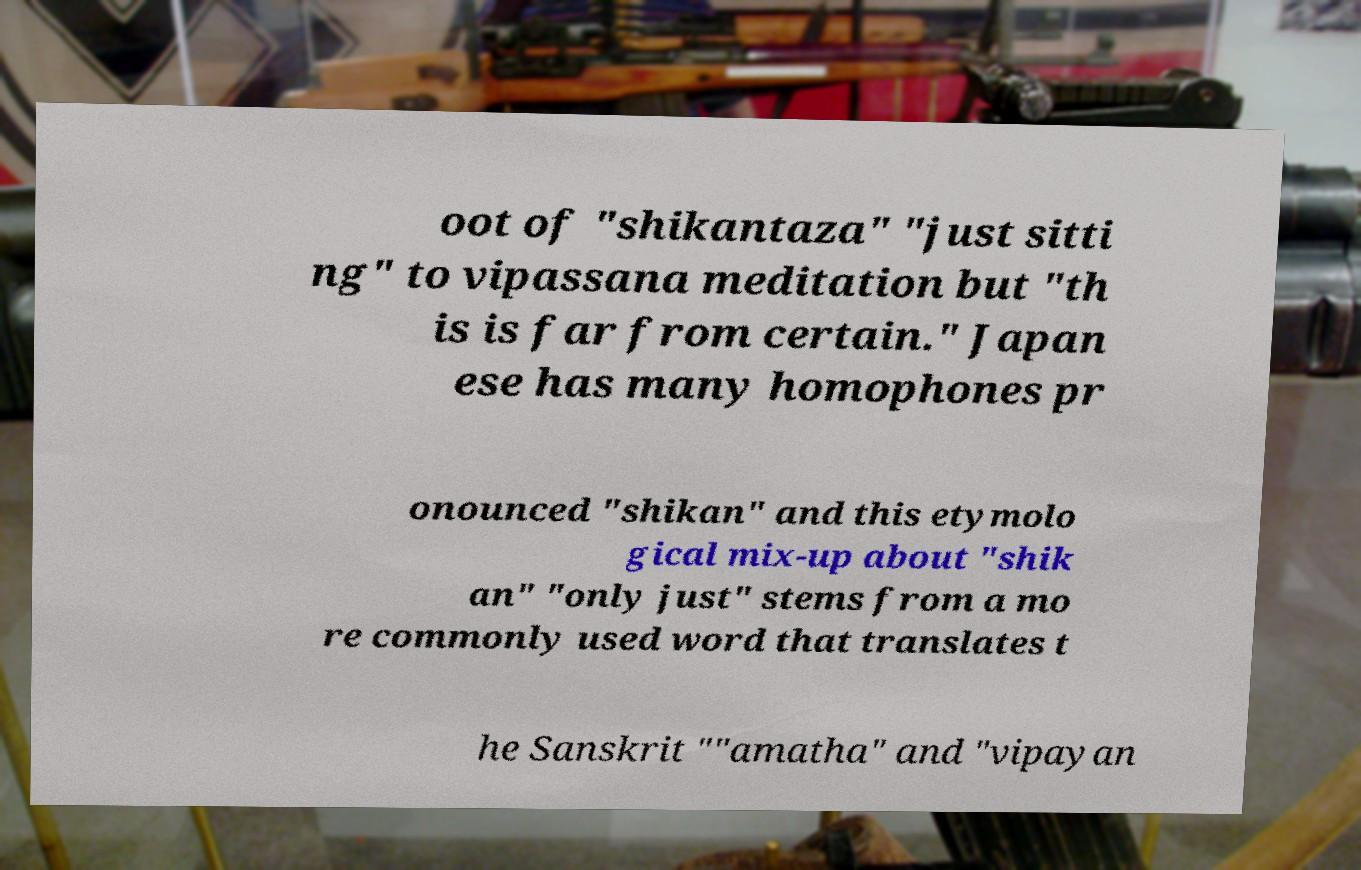There's text embedded in this image that I need extracted. Can you transcribe it verbatim? oot of "shikantaza" "just sitti ng" to vipassana meditation but "th is is far from certain." Japan ese has many homophones pr onounced "shikan" and this etymolo gical mix-up about "shik an" "only just" stems from a mo re commonly used word that translates t he Sanskrit ""amatha" and "vipayan 